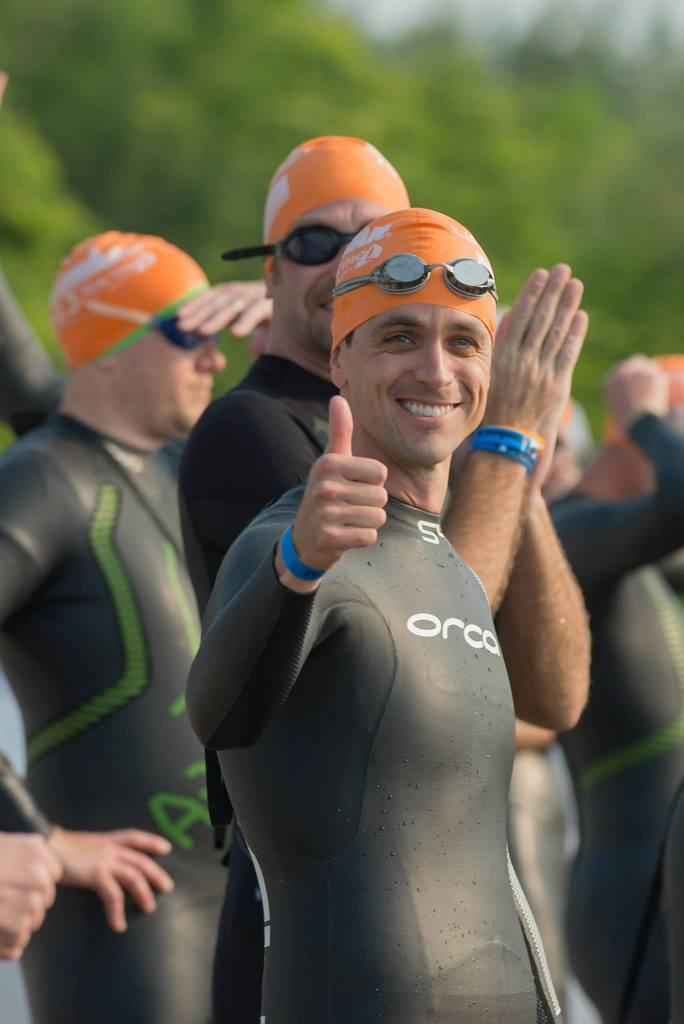What can be seen in the image? There is a group of men in the image. What are the men wearing? The men are wearing swimming costumes. What is the first person doing with his hand? The first person is showing thumbs up with his hand. What is the facial expression of the first person? The first person is smiling. How is the background of the first person depicted? The background of the first person is blurred. What type of soda is the first person holding in the image? There is no soda present in the image; the first person is showing thumbs up with his hand. 